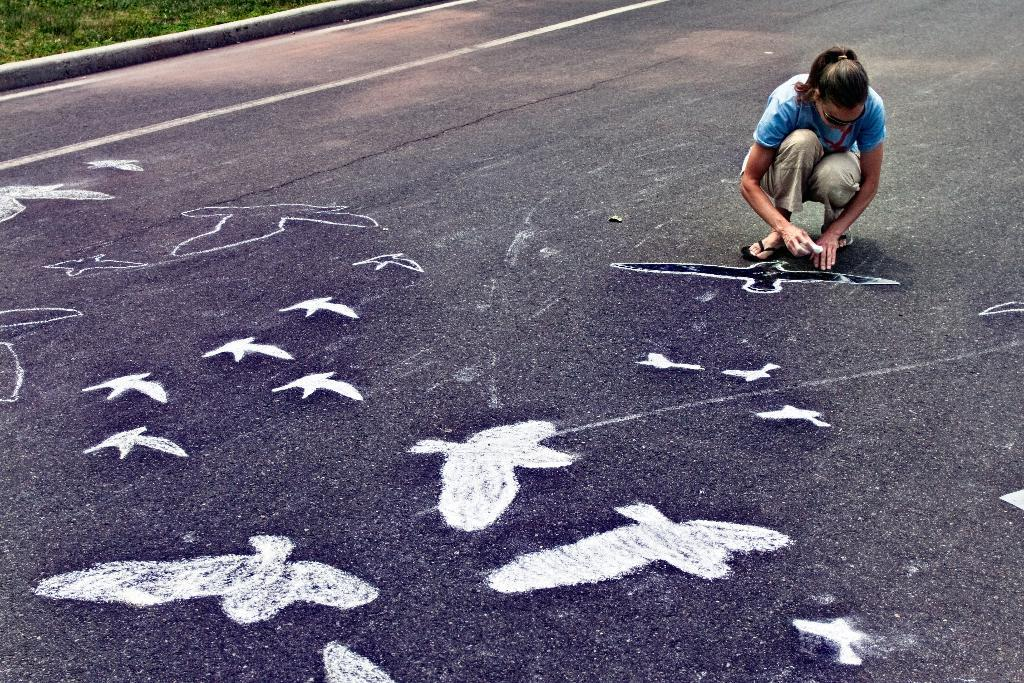Who is present in the image? There is a woman in the image. What is the woman holding in her hand? The woman is holding a chalk. What can be seen on the road in the image? There are paintings of birds on the road. What type of vegetation is visible in the top left corner of the image? There is grass on the land in the top left corner of the image. What type of doll can be seen playing with the paint in the image? There is no doll or paint present in the image. How does the woman use the chalk to create a way in the image? The image does not show the woman using the chalk to create a way; she is simply holding it. 